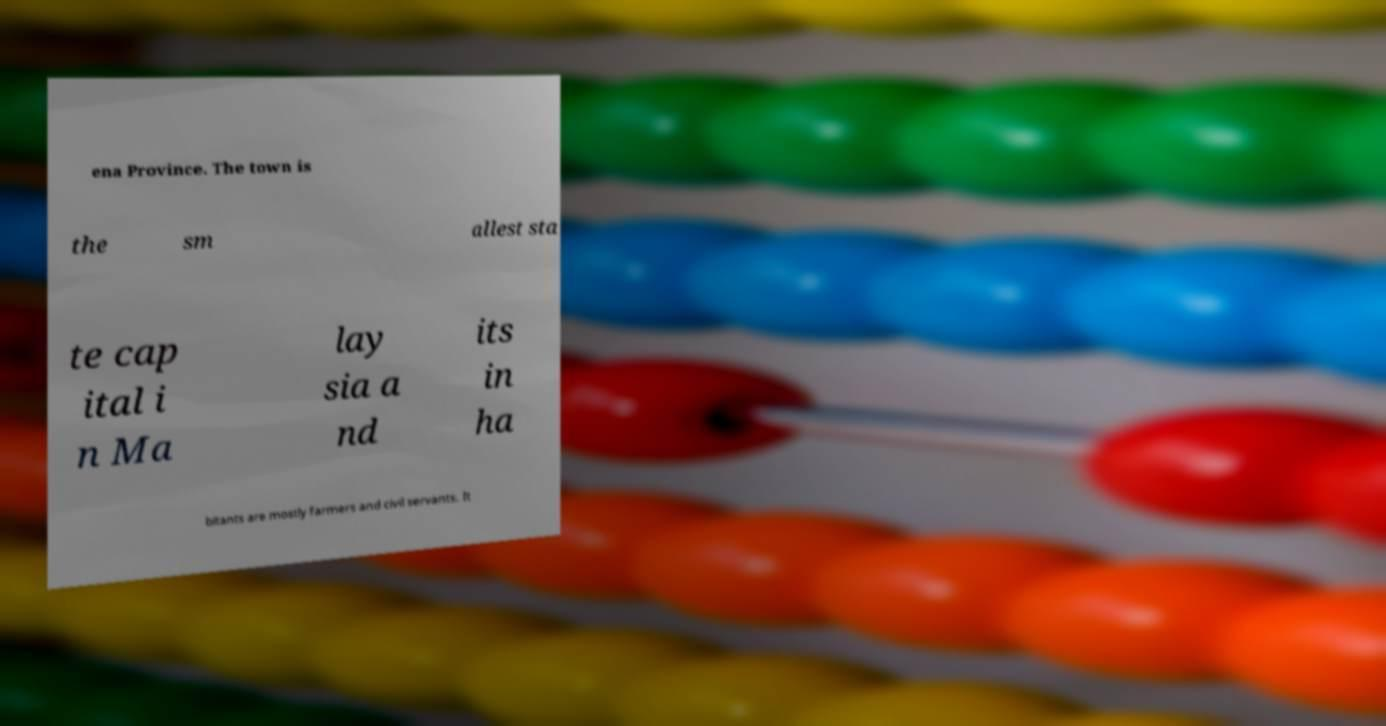Can you accurately transcribe the text from the provided image for me? ena Province. The town is the sm allest sta te cap ital i n Ma lay sia a nd its in ha bitants are mostly farmers and civil servants. It 